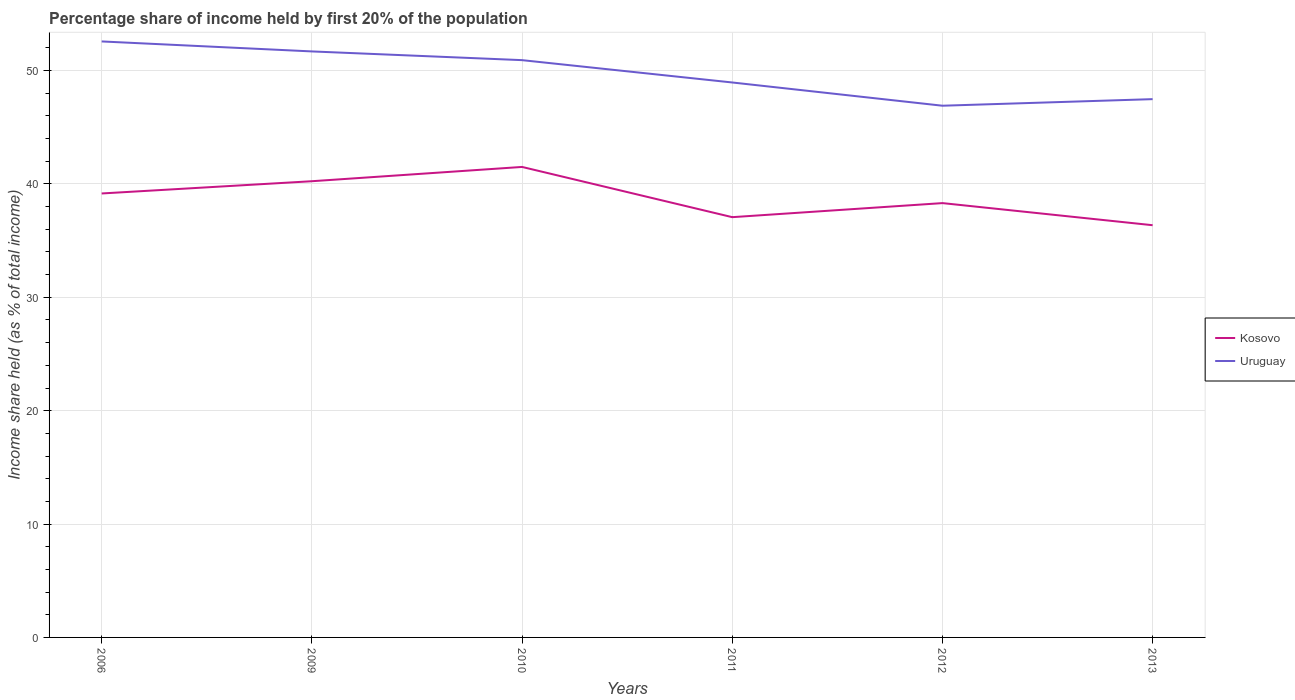Is the number of lines equal to the number of legend labels?
Keep it short and to the point. Yes. Across all years, what is the maximum share of income held by first 20% of the population in Uruguay?
Your response must be concise. 46.9. In which year was the share of income held by first 20% of the population in Kosovo maximum?
Offer a terse response. 2013. What is the total share of income held by first 20% of the population in Kosovo in the graph?
Provide a short and direct response. 1.95. What is the difference between the highest and the second highest share of income held by first 20% of the population in Kosovo?
Your answer should be very brief. 5.14. How many lines are there?
Give a very brief answer. 2. How many years are there in the graph?
Provide a short and direct response. 6. What is the difference between two consecutive major ticks on the Y-axis?
Provide a short and direct response. 10. Does the graph contain any zero values?
Provide a succinct answer. No. Does the graph contain grids?
Give a very brief answer. Yes. Where does the legend appear in the graph?
Your answer should be compact. Center right. What is the title of the graph?
Provide a succinct answer. Percentage share of income held by first 20% of the population. Does "Middle income" appear as one of the legend labels in the graph?
Keep it short and to the point. No. What is the label or title of the Y-axis?
Provide a short and direct response. Income share held (as % of total income). What is the Income share held (as % of total income) in Kosovo in 2006?
Your response must be concise. 39.16. What is the Income share held (as % of total income) in Uruguay in 2006?
Provide a short and direct response. 52.57. What is the Income share held (as % of total income) in Kosovo in 2009?
Your response must be concise. 40.24. What is the Income share held (as % of total income) of Uruguay in 2009?
Your answer should be compact. 51.69. What is the Income share held (as % of total income) in Kosovo in 2010?
Give a very brief answer. 41.5. What is the Income share held (as % of total income) of Uruguay in 2010?
Provide a succinct answer. 50.92. What is the Income share held (as % of total income) of Kosovo in 2011?
Offer a terse response. 37.07. What is the Income share held (as % of total income) of Uruguay in 2011?
Provide a succinct answer. 48.95. What is the Income share held (as % of total income) of Kosovo in 2012?
Make the answer very short. 38.31. What is the Income share held (as % of total income) in Uruguay in 2012?
Offer a terse response. 46.9. What is the Income share held (as % of total income) in Kosovo in 2013?
Offer a very short reply. 36.36. What is the Income share held (as % of total income) of Uruguay in 2013?
Your answer should be very brief. 47.48. Across all years, what is the maximum Income share held (as % of total income) in Kosovo?
Offer a very short reply. 41.5. Across all years, what is the maximum Income share held (as % of total income) in Uruguay?
Ensure brevity in your answer.  52.57. Across all years, what is the minimum Income share held (as % of total income) in Kosovo?
Make the answer very short. 36.36. Across all years, what is the minimum Income share held (as % of total income) in Uruguay?
Keep it short and to the point. 46.9. What is the total Income share held (as % of total income) of Kosovo in the graph?
Your answer should be compact. 232.64. What is the total Income share held (as % of total income) in Uruguay in the graph?
Provide a succinct answer. 298.51. What is the difference between the Income share held (as % of total income) in Kosovo in 2006 and that in 2009?
Your answer should be very brief. -1.08. What is the difference between the Income share held (as % of total income) in Uruguay in 2006 and that in 2009?
Offer a very short reply. 0.88. What is the difference between the Income share held (as % of total income) in Kosovo in 2006 and that in 2010?
Make the answer very short. -2.34. What is the difference between the Income share held (as % of total income) of Uruguay in 2006 and that in 2010?
Your response must be concise. 1.65. What is the difference between the Income share held (as % of total income) of Kosovo in 2006 and that in 2011?
Offer a very short reply. 2.09. What is the difference between the Income share held (as % of total income) in Uruguay in 2006 and that in 2011?
Offer a terse response. 3.62. What is the difference between the Income share held (as % of total income) in Kosovo in 2006 and that in 2012?
Offer a terse response. 0.85. What is the difference between the Income share held (as % of total income) in Uruguay in 2006 and that in 2012?
Give a very brief answer. 5.67. What is the difference between the Income share held (as % of total income) of Kosovo in 2006 and that in 2013?
Your answer should be very brief. 2.8. What is the difference between the Income share held (as % of total income) in Uruguay in 2006 and that in 2013?
Make the answer very short. 5.09. What is the difference between the Income share held (as % of total income) of Kosovo in 2009 and that in 2010?
Your answer should be compact. -1.26. What is the difference between the Income share held (as % of total income) in Uruguay in 2009 and that in 2010?
Provide a short and direct response. 0.77. What is the difference between the Income share held (as % of total income) in Kosovo in 2009 and that in 2011?
Provide a short and direct response. 3.17. What is the difference between the Income share held (as % of total income) of Uruguay in 2009 and that in 2011?
Make the answer very short. 2.74. What is the difference between the Income share held (as % of total income) in Kosovo in 2009 and that in 2012?
Ensure brevity in your answer.  1.93. What is the difference between the Income share held (as % of total income) of Uruguay in 2009 and that in 2012?
Offer a terse response. 4.79. What is the difference between the Income share held (as % of total income) of Kosovo in 2009 and that in 2013?
Your response must be concise. 3.88. What is the difference between the Income share held (as % of total income) of Uruguay in 2009 and that in 2013?
Make the answer very short. 4.21. What is the difference between the Income share held (as % of total income) of Kosovo in 2010 and that in 2011?
Keep it short and to the point. 4.43. What is the difference between the Income share held (as % of total income) in Uruguay in 2010 and that in 2011?
Provide a succinct answer. 1.97. What is the difference between the Income share held (as % of total income) in Kosovo in 2010 and that in 2012?
Offer a terse response. 3.19. What is the difference between the Income share held (as % of total income) of Uruguay in 2010 and that in 2012?
Give a very brief answer. 4.02. What is the difference between the Income share held (as % of total income) in Kosovo in 2010 and that in 2013?
Ensure brevity in your answer.  5.14. What is the difference between the Income share held (as % of total income) of Uruguay in 2010 and that in 2013?
Your answer should be very brief. 3.44. What is the difference between the Income share held (as % of total income) of Kosovo in 2011 and that in 2012?
Keep it short and to the point. -1.24. What is the difference between the Income share held (as % of total income) in Uruguay in 2011 and that in 2012?
Ensure brevity in your answer.  2.05. What is the difference between the Income share held (as % of total income) in Kosovo in 2011 and that in 2013?
Offer a terse response. 0.71. What is the difference between the Income share held (as % of total income) of Uruguay in 2011 and that in 2013?
Ensure brevity in your answer.  1.47. What is the difference between the Income share held (as % of total income) in Kosovo in 2012 and that in 2013?
Ensure brevity in your answer.  1.95. What is the difference between the Income share held (as % of total income) in Uruguay in 2012 and that in 2013?
Keep it short and to the point. -0.58. What is the difference between the Income share held (as % of total income) in Kosovo in 2006 and the Income share held (as % of total income) in Uruguay in 2009?
Your answer should be very brief. -12.53. What is the difference between the Income share held (as % of total income) in Kosovo in 2006 and the Income share held (as % of total income) in Uruguay in 2010?
Give a very brief answer. -11.76. What is the difference between the Income share held (as % of total income) in Kosovo in 2006 and the Income share held (as % of total income) in Uruguay in 2011?
Provide a short and direct response. -9.79. What is the difference between the Income share held (as % of total income) of Kosovo in 2006 and the Income share held (as % of total income) of Uruguay in 2012?
Provide a short and direct response. -7.74. What is the difference between the Income share held (as % of total income) of Kosovo in 2006 and the Income share held (as % of total income) of Uruguay in 2013?
Your answer should be compact. -8.32. What is the difference between the Income share held (as % of total income) in Kosovo in 2009 and the Income share held (as % of total income) in Uruguay in 2010?
Keep it short and to the point. -10.68. What is the difference between the Income share held (as % of total income) in Kosovo in 2009 and the Income share held (as % of total income) in Uruguay in 2011?
Your response must be concise. -8.71. What is the difference between the Income share held (as % of total income) of Kosovo in 2009 and the Income share held (as % of total income) of Uruguay in 2012?
Your answer should be compact. -6.66. What is the difference between the Income share held (as % of total income) in Kosovo in 2009 and the Income share held (as % of total income) in Uruguay in 2013?
Provide a short and direct response. -7.24. What is the difference between the Income share held (as % of total income) in Kosovo in 2010 and the Income share held (as % of total income) in Uruguay in 2011?
Give a very brief answer. -7.45. What is the difference between the Income share held (as % of total income) of Kosovo in 2010 and the Income share held (as % of total income) of Uruguay in 2012?
Offer a terse response. -5.4. What is the difference between the Income share held (as % of total income) of Kosovo in 2010 and the Income share held (as % of total income) of Uruguay in 2013?
Make the answer very short. -5.98. What is the difference between the Income share held (as % of total income) of Kosovo in 2011 and the Income share held (as % of total income) of Uruguay in 2012?
Provide a succinct answer. -9.83. What is the difference between the Income share held (as % of total income) in Kosovo in 2011 and the Income share held (as % of total income) in Uruguay in 2013?
Offer a terse response. -10.41. What is the difference between the Income share held (as % of total income) of Kosovo in 2012 and the Income share held (as % of total income) of Uruguay in 2013?
Offer a terse response. -9.17. What is the average Income share held (as % of total income) in Kosovo per year?
Give a very brief answer. 38.77. What is the average Income share held (as % of total income) in Uruguay per year?
Keep it short and to the point. 49.75. In the year 2006, what is the difference between the Income share held (as % of total income) in Kosovo and Income share held (as % of total income) in Uruguay?
Offer a very short reply. -13.41. In the year 2009, what is the difference between the Income share held (as % of total income) in Kosovo and Income share held (as % of total income) in Uruguay?
Your response must be concise. -11.45. In the year 2010, what is the difference between the Income share held (as % of total income) in Kosovo and Income share held (as % of total income) in Uruguay?
Keep it short and to the point. -9.42. In the year 2011, what is the difference between the Income share held (as % of total income) of Kosovo and Income share held (as % of total income) of Uruguay?
Provide a succinct answer. -11.88. In the year 2012, what is the difference between the Income share held (as % of total income) in Kosovo and Income share held (as % of total income) in Uruguay?
Your answer should be very brief. -8.59. In the year 2013, what is the difference between the Income share held (as % of total income) of Kosovo and Income share held (as % of total income) of Uruguay?
Provide a short and direct response. -11.12. What is the ratio of the Income share held (as % of total income) in Kosovo in 2006 to that in 2009?
Your answer should be very brief. 0.97. What is the ratio of the Income share held (as % of total income) of Uruguay in 2006 to that in 2009?
Offer a very short reply. 1.02. What is the ratio of the Income share held (as % of total income) of Kosovo in 2006 to that in 2010?
Offer a very short reply. 0.94. What is the ratio of the Income share held (as % of total income) of Uruguay in 2006 to that in 2010?
Your response must be concise. 1.03. What is the ratio of the Income share held (as % of total income) of Kosovo in 2006 to that in 2011?
Make the answer very short. 1.06. What is the ratio of the Income share held (as % of total income) in Uruguay in 2006 to that in 2011?
Your response must be concise. 1.07. What is the ratio of the Income share held (as % of total income) in Kosovo in 2006 to that in 2012?
Provide a succinct answer. 1.02. What is the ratio of the Income share held (as % of total income) of Uruguay in 2006 to that in 2012?
Give a very brief answer. 1.12. What is the ratio of the Income share held (as % of total income) of Kosovo in 2006 to that in 2013?
Provide a short and direct response. 1.08. What is the ratio of the Income share held (as % of total income) of Uruguay in 2006 to that in 2013?
Your response must be concise. 1.11. What is the ratio of the Income share held (as % of total income) of Kosovo in 2009 to that in 2010?
Your response must be concise. 0.97. What is the ratio of the Income share held (as % of total income) in Uruguay in 2009 to that in 2010?
Provide a short and direct response. 1.02. What is the ratio of the Income share held (as % of total income) in Kosovo in 2009 to that in 2011?
Give a very brief answer. 1.09. What is the ratio of the Income share held (as % of total income) in Uruguay in 2009 to that in 2011?
Your answer should be compact. 1.06. What is the ratio of the Income share held (as % of total income) of Kosovo in 2009 to that in 2012?
Offer a terse response. 1.05. What is the ratio of the Income share held (as % of total income) in Uruguay in 2009 to that in 2012?
Keep it short and to the point. 1.1. What is the ratio of the Income share held (as % of total income) in Kosovo in 2009 to that in 2013?
Your answer should be very brief. 1.11. What is the ratio of the Income share held (as % of total income) of Uruguay in 2009 to that in 2013?
Give a very brief answer. 1.09. What is the ratio of the Income share held (as % of total income) in Kosovo in 2010 to that in 2011?
Your response must be concise. 1.12. What is the ratio of the Income share held (as % of total income) of Uruguay in 2010 to that in 2011?
Offer a very short reply. 1.04. What is the ratio of the Income share held (as % of total income) in Kosovo in 2010 to that in 2012?
Make the answer very short. 1.08. What is the ratio of the Income share held (as % of total income) in Uruguay in 2010 to that in 2012?
Give a very brief answer. 1.09. What is the ratio of the Income share held (as % of total income) in Kosovo in 2010 to that in 2013?
Offer a very short reply. 1.14. What is the ratio of the Income share held (as % of total income) in Uruguay in 2010 to that in 2013?
Keep it short and to the point. 1.07. What is the ratio of the Income share held (as % of total income) of Kosovo in 2011 to that in 2012?
Ensure brevity in your answer.  0.97. What is the ratio of the Income share held (as % of total income) in Uruguay in 2011 to that in 2012?
Your answer should be compact. 1.04. What is the ratio of the Income share held (as % of total income) in Kosovo in 2011 to that in 2013?
Ensure brevity in your answer.  1.02. What is the ratio of the Income share held (as % of total income) in Uruguay in 2011 to that in 2013?
Ensure brevity in your answer.  1.03. What is the ratio of the Income share held (as % of total income) of Kosovo in 2012 to that in 2013?
Provide a short and direct response. 1.05. What is the difference between the highest and the second highest Income share held (as % of total income) in Kosovo?
Offer a terse response. 1.26. What is the difference between the highest and the second highest Income share held (as % of total income) of Uruguay?
Offer a very short reply. 0.88. What is the difference between the highest and the lowest Income share held (as % of total income) in Kosovo?
Offer a terse response. 5.14. What is the difference between the highest and the lowest Income share held (as % of total income) in Uruguay?
Your response must be concise. 5.67. 